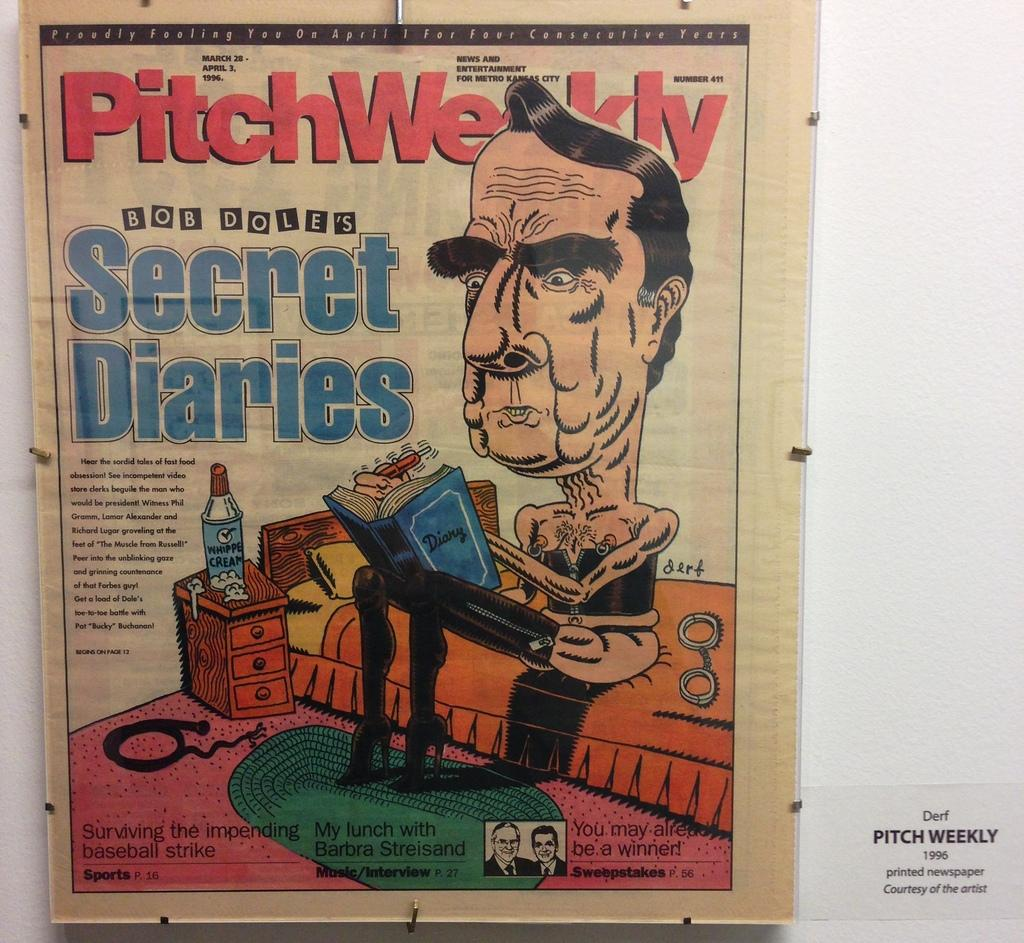<image>
Offer a succinct explanation of the picture presented. A newspaper insert called the PitchWeekly Bob Dole's Secret Diaries with a cartoon of Bob Dole sitting on a couch. 